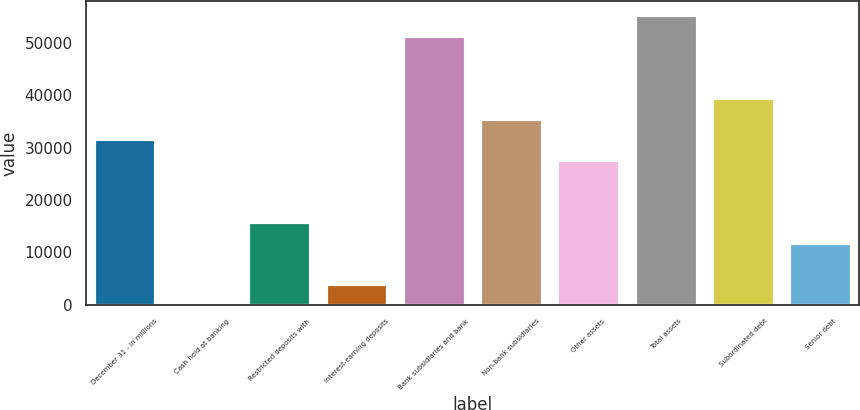Convert chart to OTSL. <chart><loc_0><loc_0><loc_500><loc_500><bar_chart><fcel>December 31 - in millions<fcel>Cash held at banking<fcel>Restricted deposits with<fcel>Interest-earning deposits<fcel>Bank subsidiaries and bank<fcel>Non-bank subsidiaries<fcel>Other assets<fcel>Total assets<fcel>Subordinated debt<fcel>Senior debt<nl><fcel>31579.6<fcel>2<fcel>15790.8<fcel>3949.2<fcel>51315.6<fcel>35526.8<fcel>27632.4<fcel>55262.8<fcel>39474<fcel>11843.6<nl></chart> 